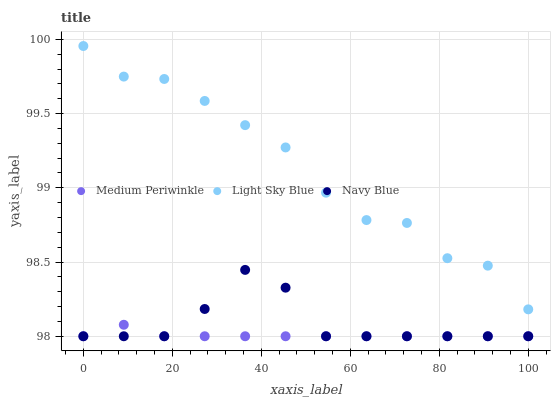Does Medium Periwinkle have the minimum area under the curve?
Answer yes or no. Yes. Does Light Sky Blue have the maximum area under the curve?
Answer yes or no. Yes. Does Light Sky Blue have the minimum area under the curve?
Answer yes or no. No. Does Medium Periwinkle have the maximum area under the curve?
Answer yes or no. No. Is Medium Periwinkle the smoothest?
Answer yes or no. Yes. Is Light Sky Blue the roughest?
Answer yes or no. Yes. Is Light Sky Blue the smoothest?
Answer yes or no. No. Is Medium Periwinkle the roughest?
Answer yes or no. No. Does Navy Blue have the lowest value?
Answer yes or no. Yes. Does Light Sky Blue have the lowest value?
Answer yes or no. No. Does Light Sky Blue have the highest value?
Answer yes or no. Yes. Does Medium Periwinkle have the highest value?
Answer yes or no. No. Is Navy Blue less than Light Sky Blue?
Answer yes or no. Yes. Is Light Sky Blue greater than Navy Blue?
Answer yes or no. Yes. Does Medium Periwinkle intersect Navy Blue?
Answer yes or no. Yes. Is Medium Periwinkle less than Navy Blue?
Answer yes or no. No. Is Medium Periwinkle greater than Navy Blue?
Answer yes or no. No. Does Navy Blue intersect Light Sky Blue?
Answer yes or no. No. 